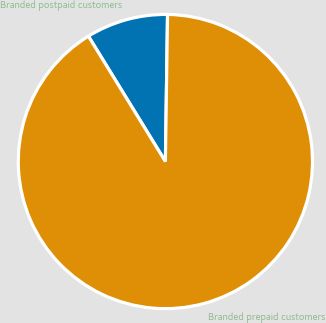<chart> <loc_0><loc_0><loc_500><loc_500><pie_chart><fcel>Branded postpaid customers<fcel>Branded prepaid customers<nl><fcel>9.0%<fcel>91.0%<nl></chart> 